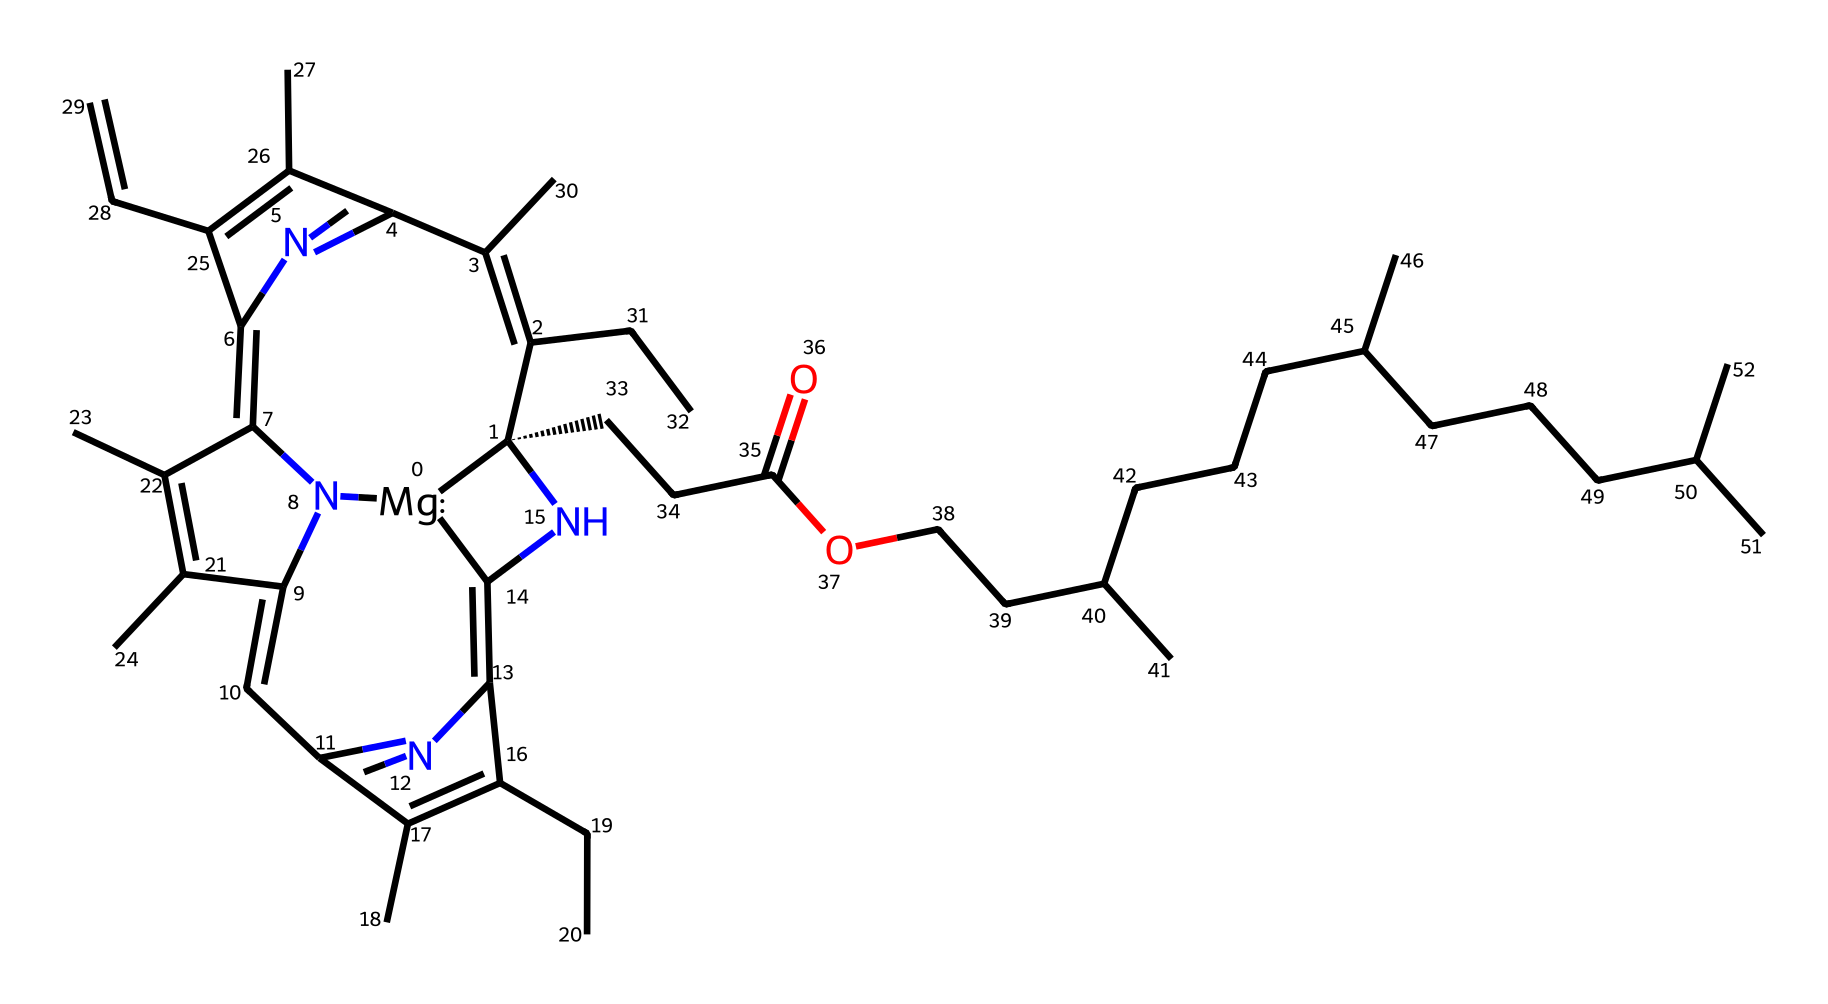What is the central metal ion in chlorophyll? The structure reveals the presence of a magnesium atom, denoted as [Mg] in the SMILES representation. This indicates that magnesium is the central metal ion in the chlorophyll molecule.
Answer: magnesium How many nitrogen atoms are present in the chlorophyll structure? By counting the nitrogen atoms in the provided SMILES, we can identify that there are five nitrogen atoms present throughout the structure.
Answer: five What functional groups are visible in this chlorophyll molecule? Analyzing the chemical structure shows a carboxylic acid group (-COOH) as indicated by the "C(=O)O" segment in the SMILES. Additionally, the presence of double bonds indicates multiple alkenes.
Answer: carboxylic acid, alkene Which part of the chlorophyll molecule is involved in light absorption? The porphyrin-like structure of chlorophyll, specifically the conjugated double bond system (identified through the alternating double bonds), is crucial for light absorption.
Answer: conjugated double bond system What is the role of isotopes in photosynthesis related to chlorophyll? In photosynthesis, isotopes such as carbon-12 and carbon-13 can be used to track the process of carbon fixation and the transformation of carbon during photosynthesis, providing insights into metabolic pathways.
Answer: tracking carbon fixation How many rings are present in the chlorophyll molecule? By examining the structure, it's evident that there are multiple interconnected ring systems (four, based on the fused structures), commonly associated with the chlorophyll's porphyrin nature.
Answer: four What is the main type of isotope commonly studied in chlorophyll for photosynthesis research? The most commonly studied isotope in relation to chlorophyll and photosynthesis is carbon-13, as it provides information on the metabolic processes of plants.
Answer: carbon-13 